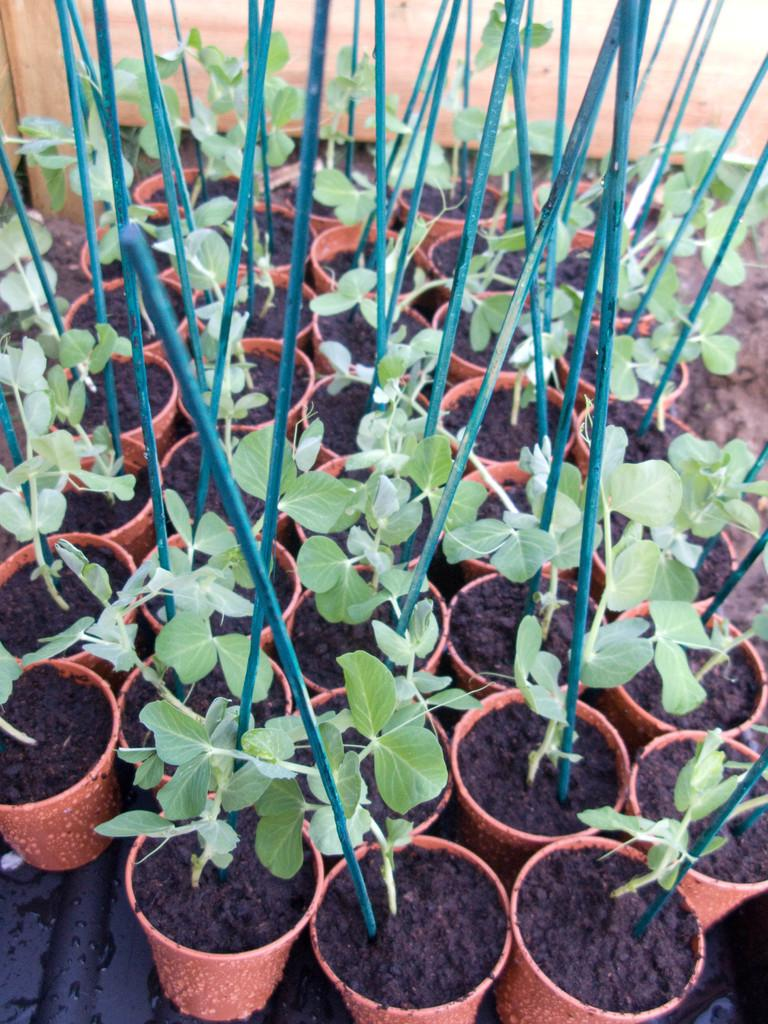What type of plants are in the image? There are potted plants in the image. What can be seen inside the pots? The pots appear to have rods in them. How many apples are hanging from the rods in the image? There are no apples present in the image; the pots have rods in them, but no apples are visible. 